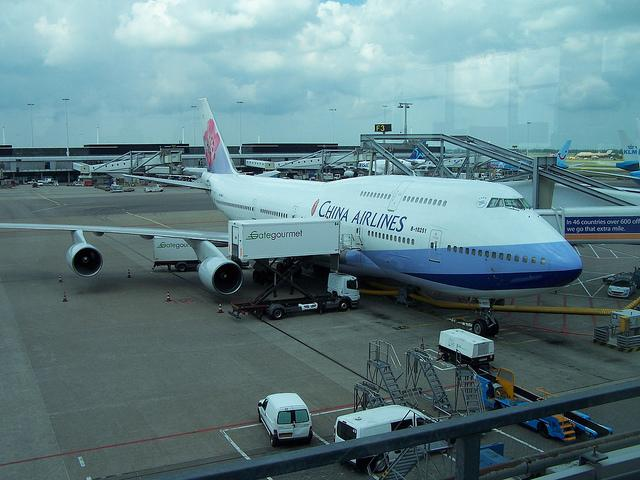How were the drivers of the cars able to park here?

Choices:
A) firemen
B) airport workers
C) police
D) postal workers airport workers 